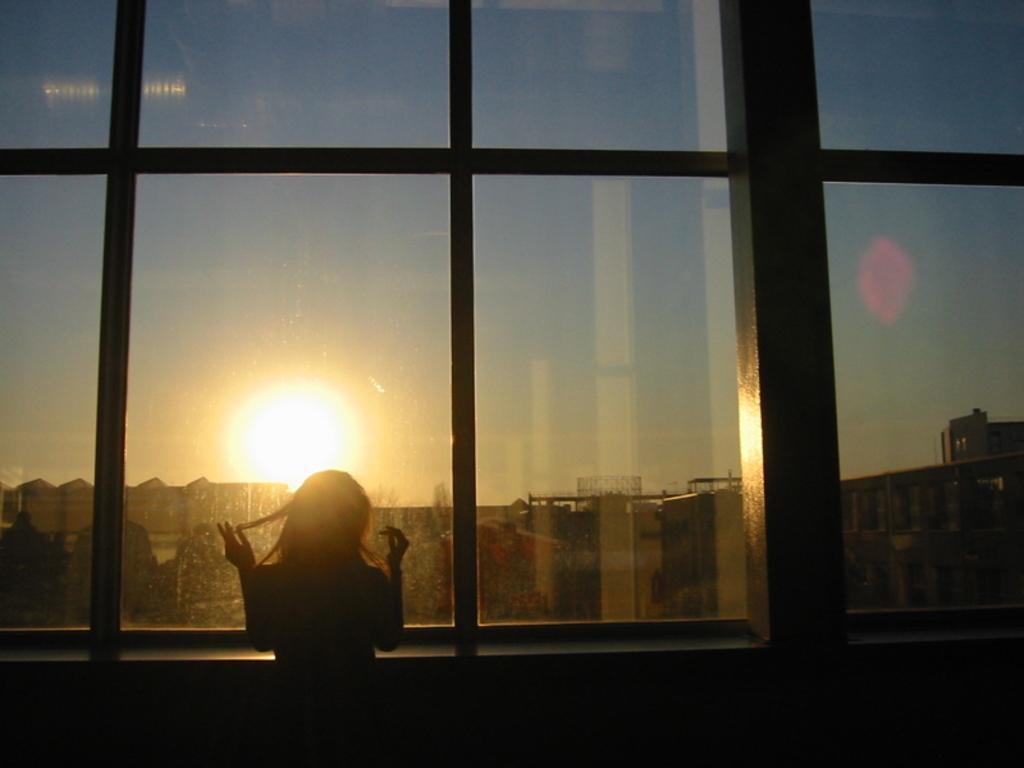How would you summarize this image in a sentence or two? In the picture I can see a woman standing and there is a glass in front of her and there are few buildings and a sun in the background. 